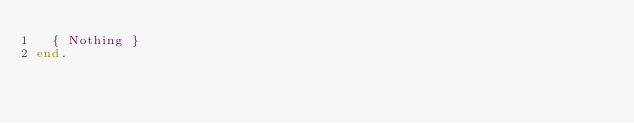<code> <loc_0><loc_0><loc_500><loc_500><_Pascal_>	{ Nothing }
end.</code> 